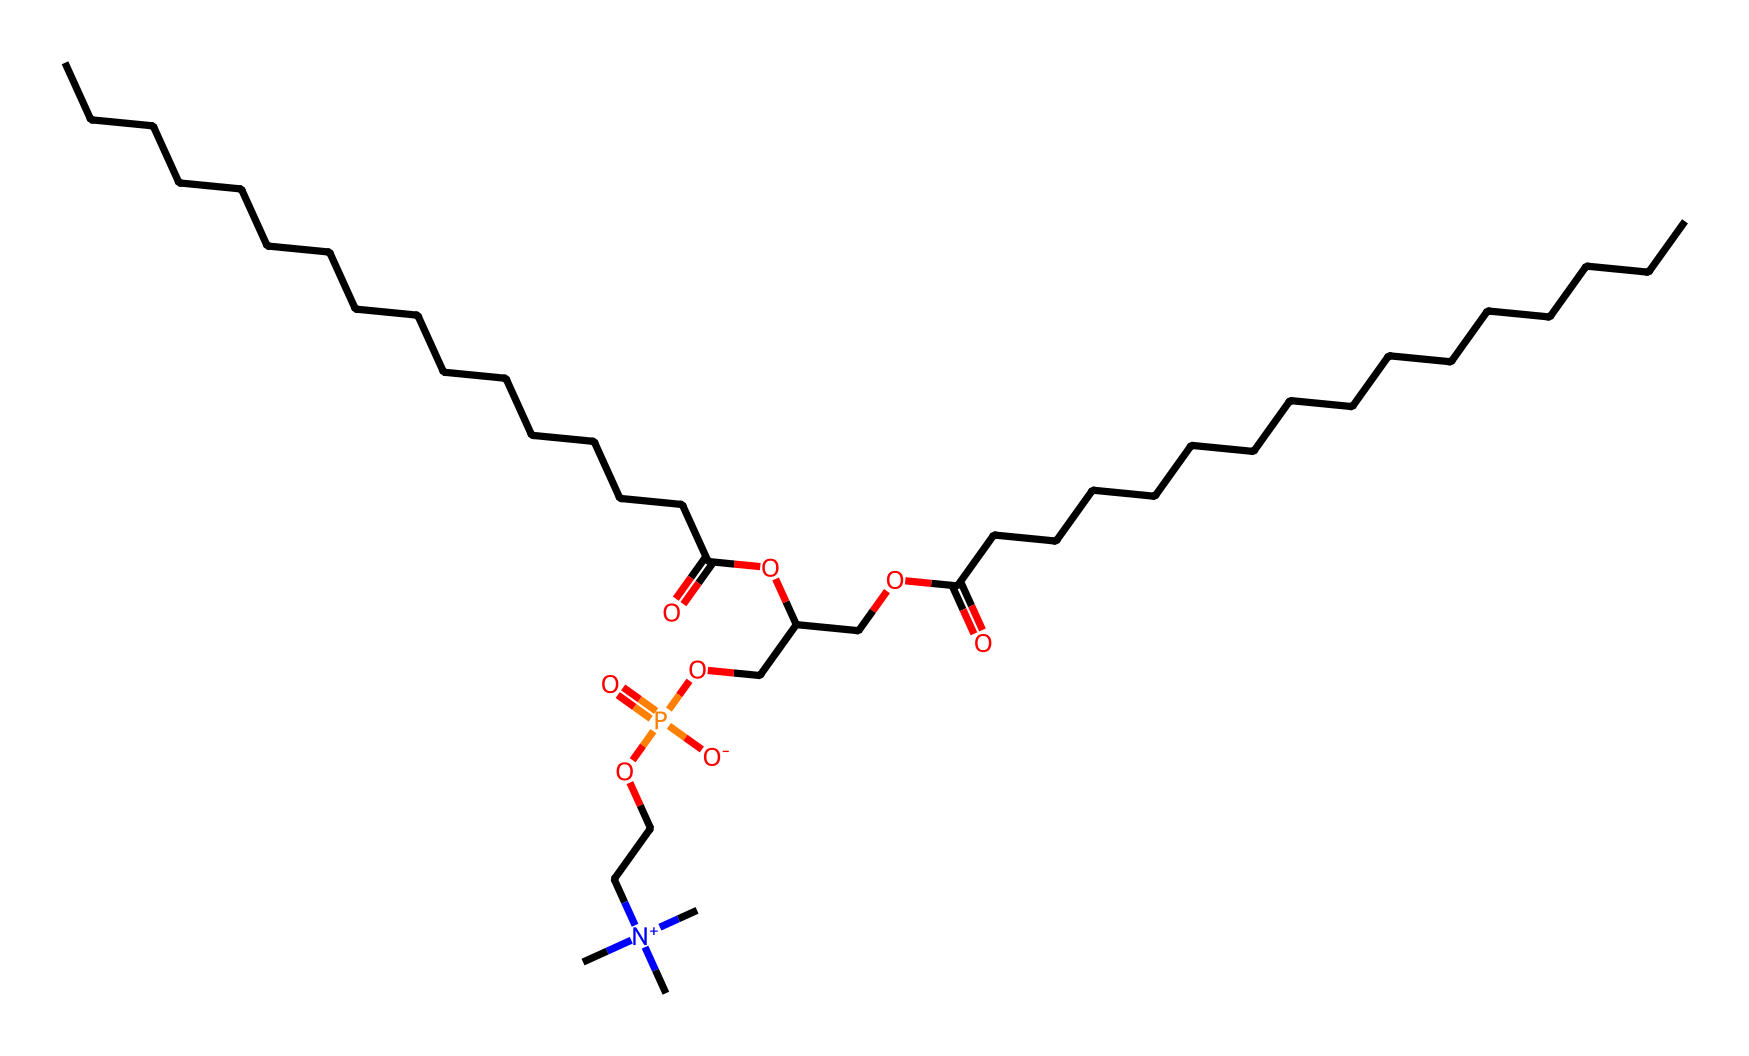What is the main functional group present in this molecule? The molecule contains a phosphate group, identifiable by the phosphorus atom bonded to four oxygens, one of which is double-bonded. This functional group is key to its classification as a phospholipid.
Answer: phosphate group How many carbon atoms are in this compound? By counting the 'C' representations in the SMILES string, we find that there are 30 carbon atoms in total, divided between the hydrophobic tails and the polar head.
Answer: 30 What type of bond connects the carbon chains to the phosphate group? The connection between the fatty acid chains and the phosphate group involves ester bonds, characterized by the oxygen atoms bonded to both the carbon and the phosphate.
Answer: ester bonds What role does this molecule play in biological membranes? This compound constitutes a phospholipid, which is essential for forming cell membranes due to its amphipathic nature, allowing it to create a bilayer structure with hydrophilic heads facing outward and hydrophobic tails inward.
Answer: phospholipid What charge does the phosphate group carry in this molecule? The phosphate group carries a negative charge due to the presence of the negatively-charged hydroxyl group bonded to phosphorus, which influences membrane charge and interactions.
Answer: negative charge How does the structure of this compound promote bilayer formation? The molecule's amphipathic characteristics, characterized by hydrophilic (polar) phosphate heads and hydrophobic (nonpolar) fatty acid tails, facilitate the spontaneous arrangement into a bilayer in an aqueous environment.
Answer: amphipathic characteristics 